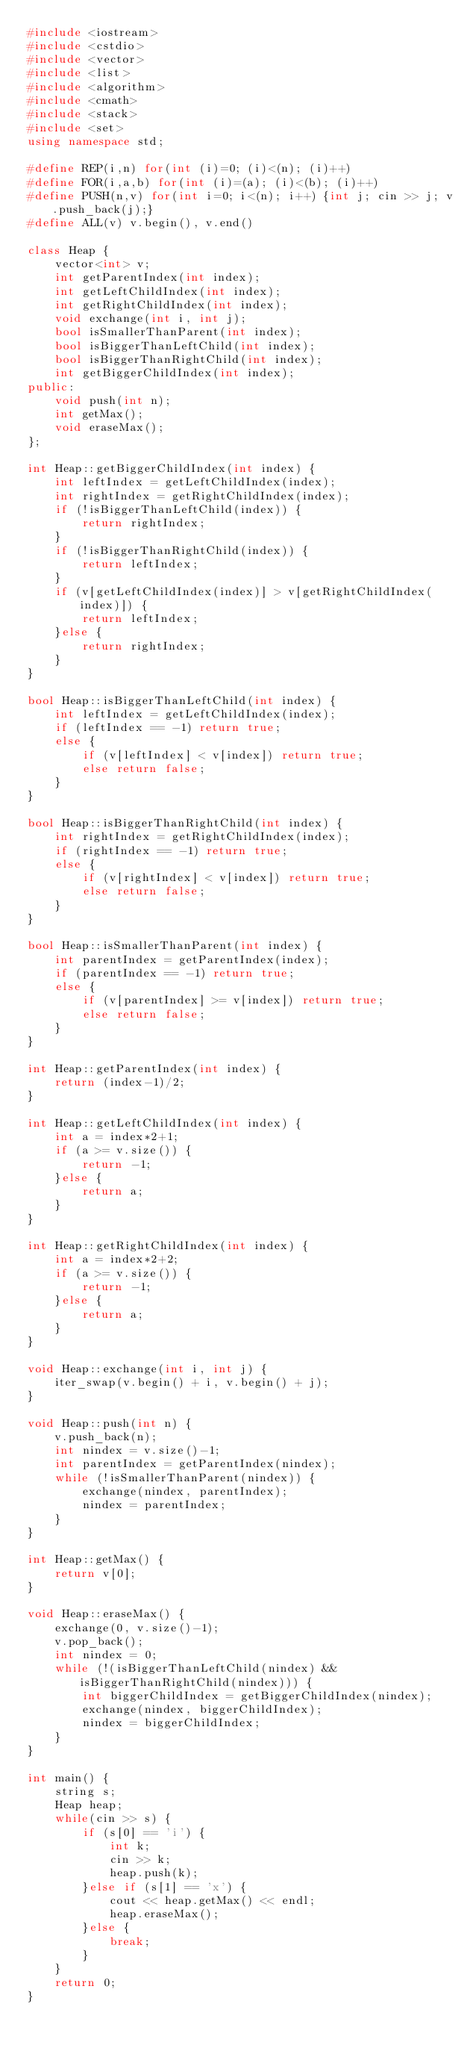<code> <loc_0><loc_0><loc_500><loc_500><_C++_>#include <iostream>
#include <cstdio>
#include <vector>
#include <list>
#include <algorithm>
#include <cmath>
#include <stack>
#include <set>
using namespace std;

#define REP(i,n) for(int (i)=0; (i)<(n); (i)++)
#define FOR(i,a,b) for(int (i)=(a); (i)<(b); (i)++)
#define PUSH(n,v) for(int i=0; i<(n); i++) {int j; cin >> j; v.push_back(j);}
#define ALL(v) v.begin(), v.end()

class Heap {
    vector<int> v;
    int getParentIndex(int index);
    int getLeftChildIndex(int index);
    int getRightChildIndex(int index);
    void exchange(int i, int j);
    bool isSmallerThanParent(int index);
    bool isBiggerThanLeftChild(int index);
    bool isBiggerThanRightChild(int index);
    int getBiggerChildIndex(int index);
public:
    void push(int n);
    int getMax();
    void eraseMax();
};

int Heap::getBiggerChildIndex(int index) {
    int leftIndex = getLeftChildIndex(index);
    int rightIndex = getRightChildIndex(index);
    if (!isBiggerThanLeftChild(index)) {
        return rightIndex;
    }
    if (!isBiggerThanRightChild(index)) {
        return leftIndex;
    }
    if (v[getLeftChildIndex(index)] > v[getRightChildIndex(index)]) {
        return leftIndex;
    }else {
        return rightIndex;
    }
}

bool Heap::isBiggerThanLeftChild(int index) {
    int leftIndex = getLeftChildIndex(index);
    if (leftIndex == -1) return true;
    else {
        if (v[leftIndex] < v[index]) return true;
        else return false;
    }
}

bool Heap::isBiggerThanRightChild(int index) {
    int rightIndex = getRightChildIndex(index);
    if (rightIndex == -1) return true;
    else {
        if (v[rightIndex] < v[index]) return true;
        else return false;
    }
}

bool Heap::isSmallerThanParent(int index) {
    int parentIndex = getParentIndex(index);
    if (parentIndex == -1) return true;
    else {
        if (v[parentIndex] >= v[index]) return true;
        else return false;
    }
}

int Heap::getParentIndex(int index) {
    return (index-1)/2;
}

int Heap::getLeftChildIndex(int index) {
    int a = index*2+1;
    if (a >= v.size()) {
        return -1;
    }else {
        return a;
    }
}

int Heap::getRightChildIndex(int index) {
    int a = index*2+2;
    if (a >= v.size()) {
        return -1;
    }else {
        return a;
    }
}

void Heap::exchange(int i, int j) {
    iter_swap(v.begin() + i, v.begin() + j);
}

void Heap::push(int n) {
    v.push_back(n);
    int nindex = v.size()-1;
    int parentIndex = getParentIndex(nindex);
    while (!isSmallerThanParent(nindex)) {
        exchange(nindex, parentIndex);
        nindex = parentIndex;
    }
}

int Heap::getMax() {
    return v[0];
}

void Heap::eraseMax() {
    exchange(0, v.size()-1);
    v.pop_back();
    int nindex = 0;
    while (!(isBiggerThanLeftChild(nindex) && isBiggerThanRightChild(nindex))) {
        int biggerChildIndex = getBiggerChildIndex(nindex);
        exchange(nindex, biggerChildIndex);
        nindex = biggerChildIndex;
    }
}

int main() {
    string s;
    Heap heap;
    while(cin >> s) {
        if (s[0] == 'i') {
            int k;
            cin >> k;
            heap.push(k);
        }else if (s[1] == 'x') {
            cout << heap.getMax() << endl;
            heap.eraseMax();
        }else {
            break;
        }
    }
    return 0;
}</code> 